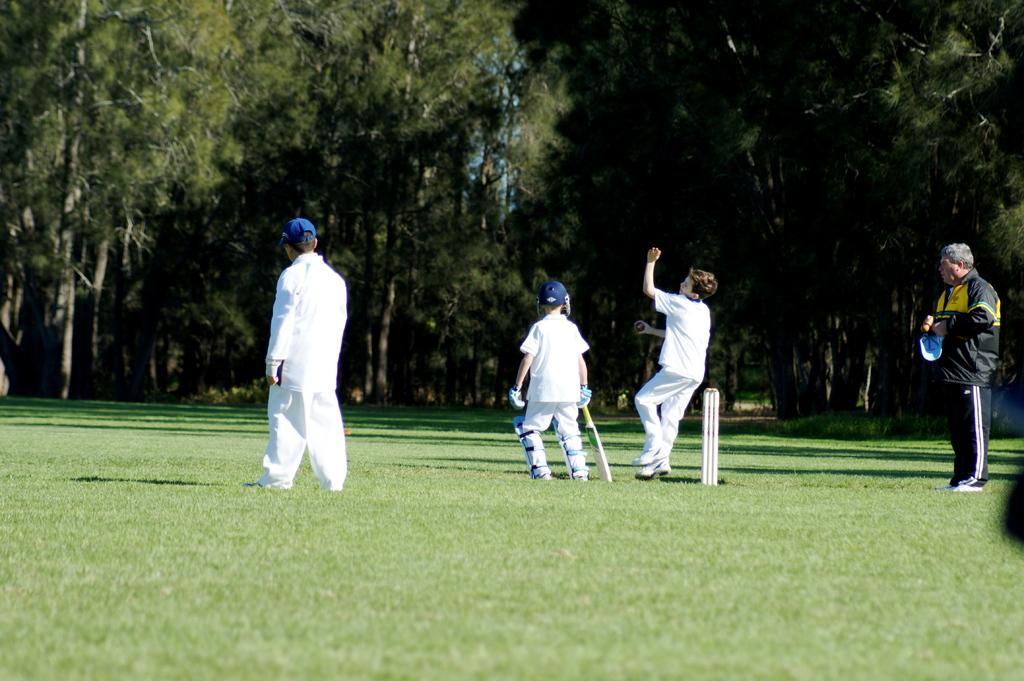Describe this image in one or two sentences. In this image there is a boy wearing a helmet. He is holding a bat. He is standing on the grassland having stumps. Beside him there is a boy holding a ball. Right side there is a person holding a cap. He is standing on the grassland. Left side there is a person wearing a cap. Background there are trees on the grassland. 